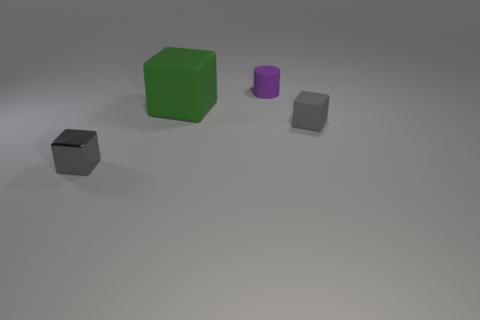Are there any other things that are the same shape as the small purple thing?
Make the answer very short. No. There is a green cube that is behind the gray block that is in front of the small gray thing behind the metallic cube; how big is it?
Give a very brief answer. Large. There is a small block right of the gray block that is left of the green rubber object; what is its color?
Give a very brief answer. Gray. There is another large object that is the same shape as the metallic object; what material is it?
Offer a terse response. Rubber. There is a small rubber cube; are there any rubber cubes behind it?
Keep it short and to the point. Yes. How many small yellow matte balls are there?
Provide a short and direct response. 0. There is a object that is behind the large green thing; how many small rubber cubes are left of it?
Give a very brief answer. 0. Does the tiny shiny object have the same color as the cube on the right side of the large green block?
Keep it short and to the point. Yes. How many small matte objects are the same shape as the gray metal thing?
Your answer should be compact. 1. What is the gray object that is on the left side of the tiny gray rubber cube made of?
Provide a succinct answer. Metal. 